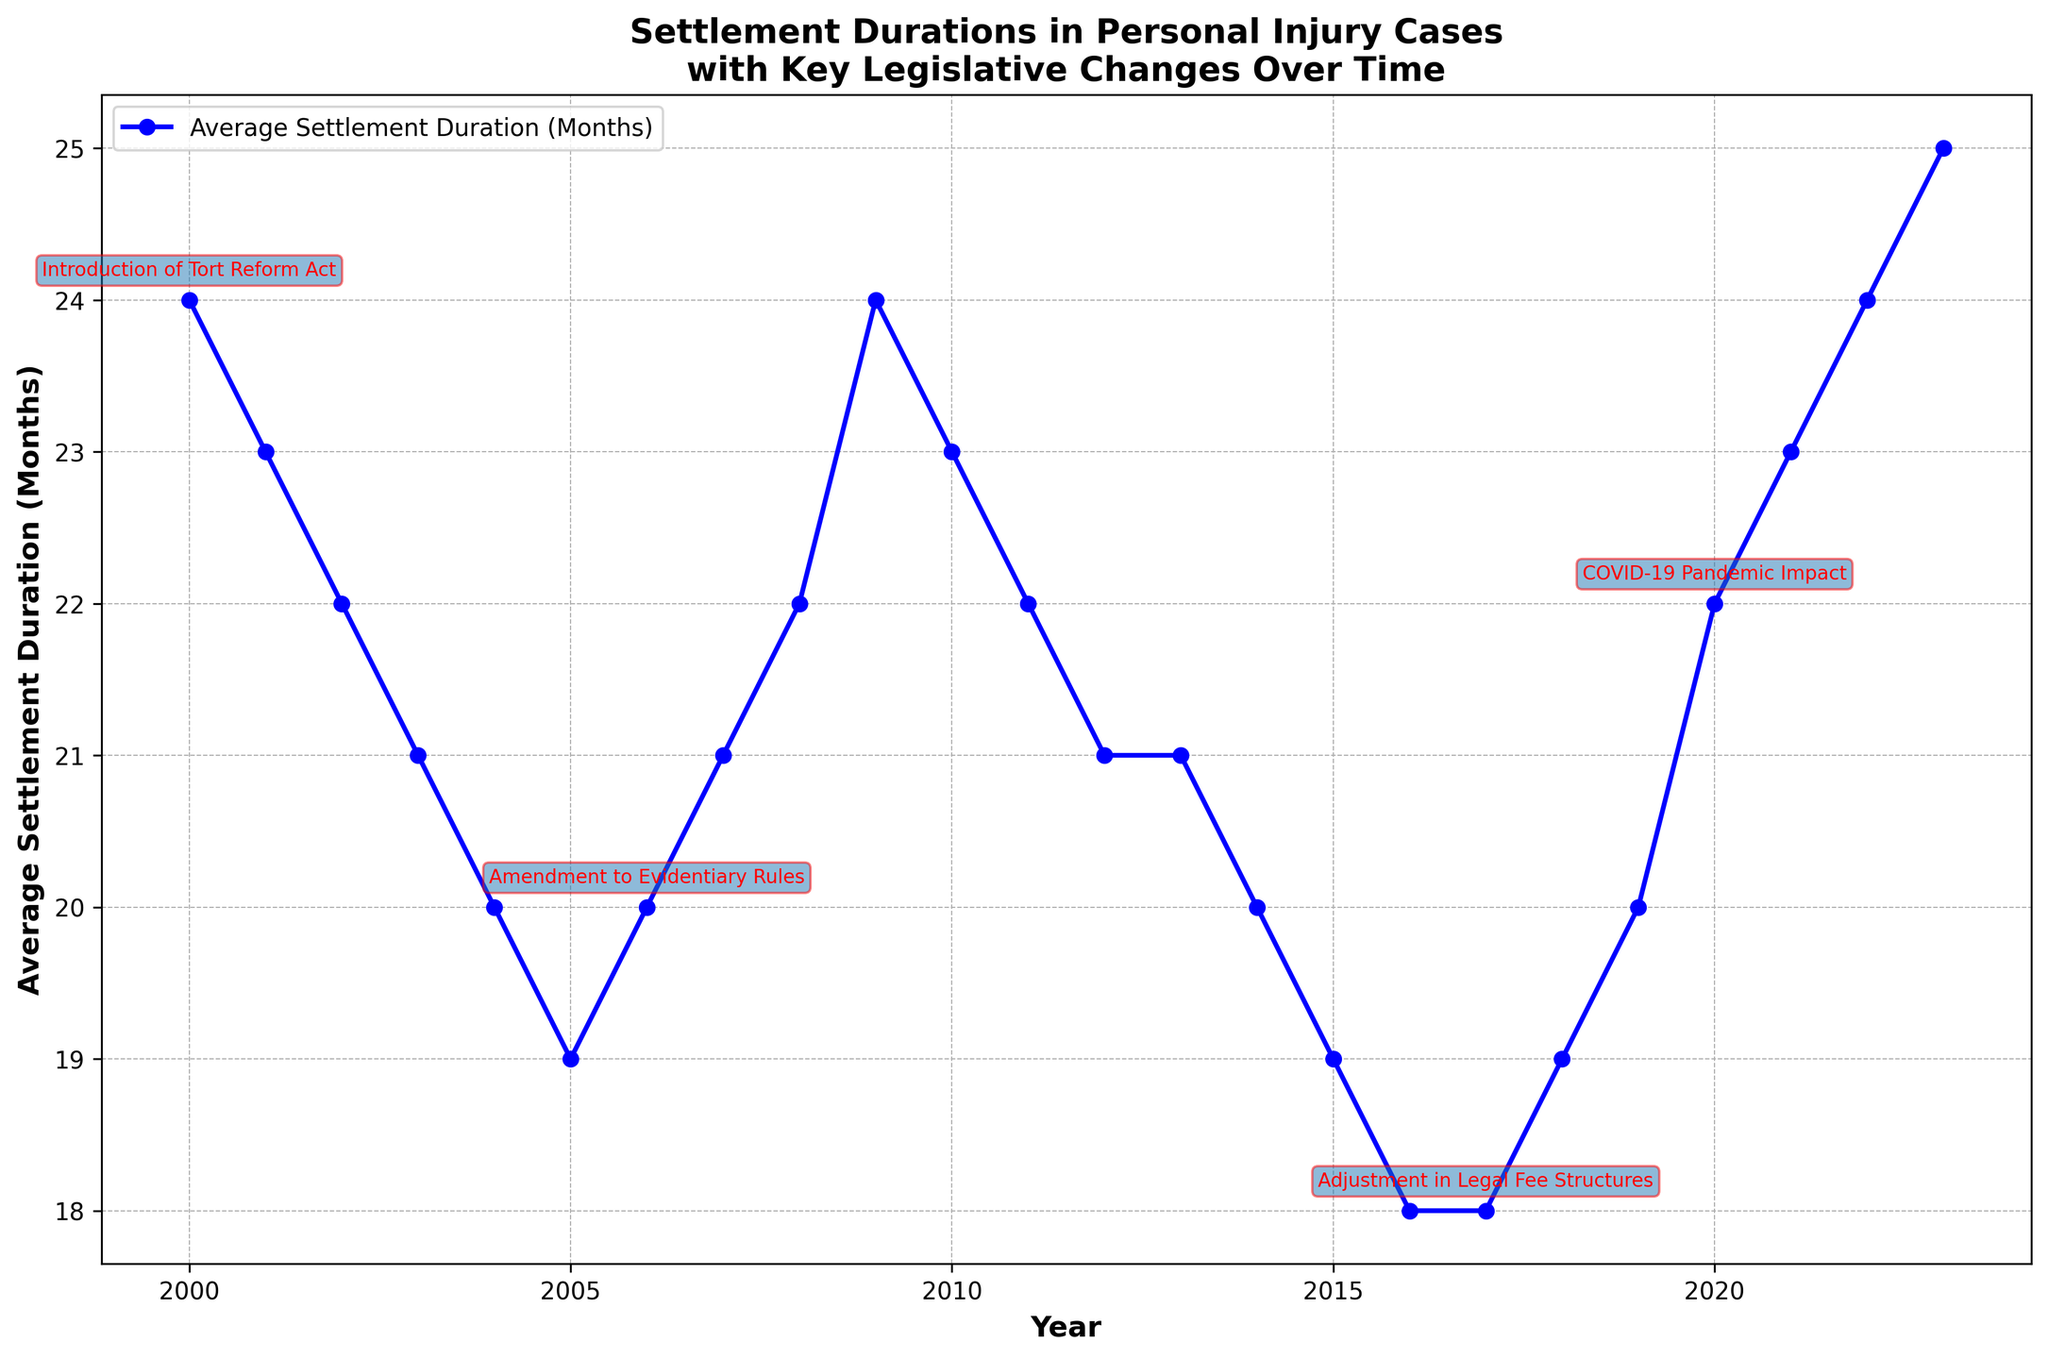What was the average settlement duration in 2005 compared to 2016? To answer this, we locate the duration for 2005 and 2016 on the plot. For 2005, the duration is 19 months, and for 2016, it is 18 months. By comparing these values: 19 (2005) > 18 (2016).
Answer: 19 months in 2005, 18 months in 2016 What was the average settlement duration before and after the introduction of the Tort Reform Act in 2000? The Tort Reform Act was introduced in 2000. The average settlement duration in 1999 (before the Act) is assumed to be higher than in 2000. For 2000, the duration is 24 months, and it generally decreases to 23, 22, 21, and so on in subsequent years. This indicates the Act may have contributed to reducing the duration from 2000 onwards.
Answer: Decreased after 2000 Which year experienced the shortest average settlement duration between 2000 and 2023? By scanning the plot, the shortest duration observed is in 2016 and 2017, both of which show an average duration of 18 months. This is the lowest value between 2000 and 2023.
Answer: 2016 and 2017 How did the average settlement duration change following the Amendment to Evidentiary Rules in 2006? The Amendment to Evidentiary Rules occurred in 2006. Checking the durations, we see it was 20 months in 2006, increasing to 21 in 2007 and 22 in 2008, suggesting an increase in settlement durations following the amendment.
Answer: Increased What significant event affected settlement durations in 2020? The plot highlights key legislative changes in red. For 2020, the COVID-19 Pandemic Impact is noted, accompanied by an increase in the average settlement duration to 22 months.
Answer: COVID-19 Pandemic Impact From 2000 to 2023, how many years had an average settlement duration equal to or less than 20 months? By examining the plot over the specified period, the years with a duration of 20 months or less are 2004, 2005, 2014, 2015, 2016, 2017, 2018, 2019. Counting these years gives a total of 8.
Answer: 8 years What was the difference in settlement durations between the year with the longest and the shortest durations? The longest duration seen on the plot is 25 months in 2023, and the shortest is 18 months in 2016 and 2017. The difference is 25 - 18 = 7 months.
Answer: 7 months In which years did the average settlement duration increase right after a key legislative change? Key legislative changes occurred in 2000, 2006, 2017, and 2020. Reviewing the plot, increases in settlement durations right after these changes are seen in 2006 (from 20 to 21), 2017 (from 18 to 19), and 2020 (from 20 to 22).
Answer: 2006, 2017, 2020 What pattern is seen in settlement durations over the years without any key legislative changes noted? Observing the periods between 2001-2005 and 2007-2013, durations generally decrease or remain stable. However, fluctuations are minimal compared to periods immediately following key legislative changes.
Answer: Decrease or stabilize 